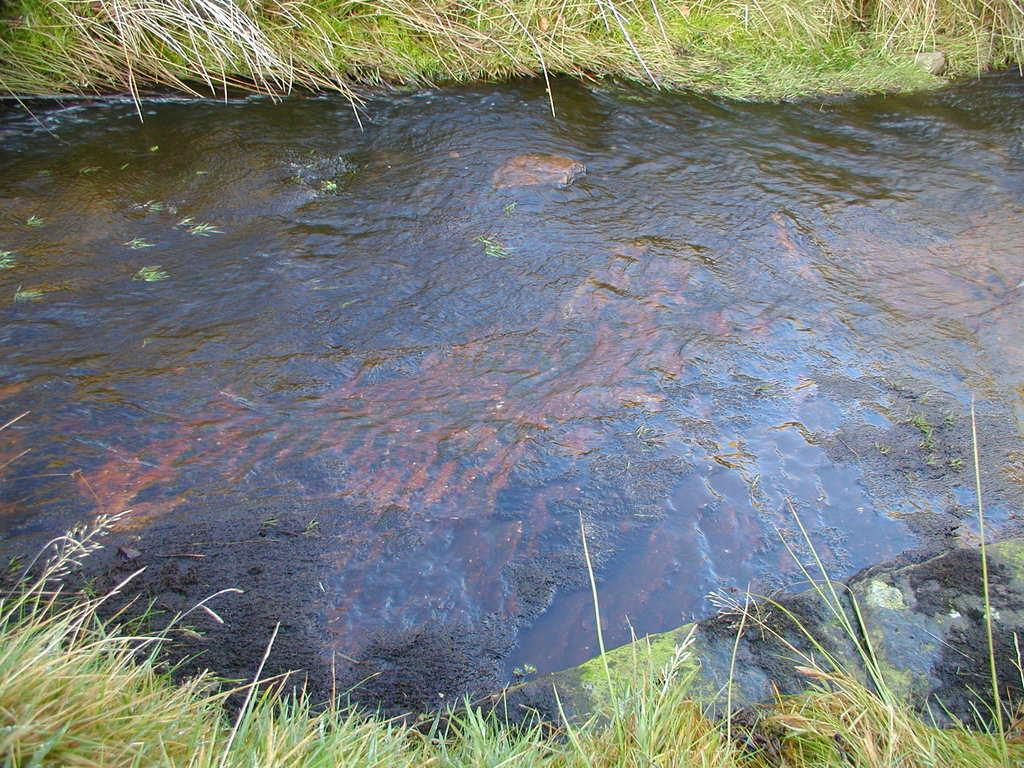What is the main feature of the image? The main feature of the image is a flowing water surface. What is the water surface flowing between? The water surface is flowing between grass. Can you describe the movement of the water in the image? The water surface is flowing, indicating that it is in motion. What type of oil can be seen floating on the water surface in the image? There is no oil present on the water surface in the image. 